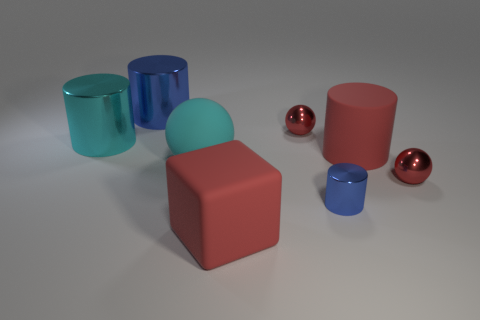Are there fewer small spheres than large red blocks?
Offer a terse response. No. Are there more cyan rubber things in front of the cyan metal cylinder than big cyan objects that are right of the big blue metal cylinder?
Your answer should be compact. No. Is the material of the cyan cylinder the same as the large blue object?
Provide a short and direct response. Yes. There is a blue metal object that is to the right of the big cube; what number of metal cylinders are in front of it?
Offer a terse response. 0. Does the rubber object that is in front of the large cyan rubber object have the same color as the large rubber cylinder?
Offer a terse response. Yes. What number of objects are either big cylinders or tiny shiny objects that are behind the large rubber cylinder?
Your answer should be compact. 4. There is a shiny thing that is on the right side of the large rubber cylinder; does it have the same shape as the small red thing that is behind the matte cylinder?
Your answer should be very brief. Yes. There is a blue object that is made of the same material as the tiny cylinder; what is its shape?
Offer a terse response. Cylinder. There is a thing that is both to the right of the large sphere and behind the big cyan cylinder; what material is it?
Offer a very short reply. Metal. Is the color of the rubber cube the same as the big matte cylinder?
Your answer should be compact. Yes. 